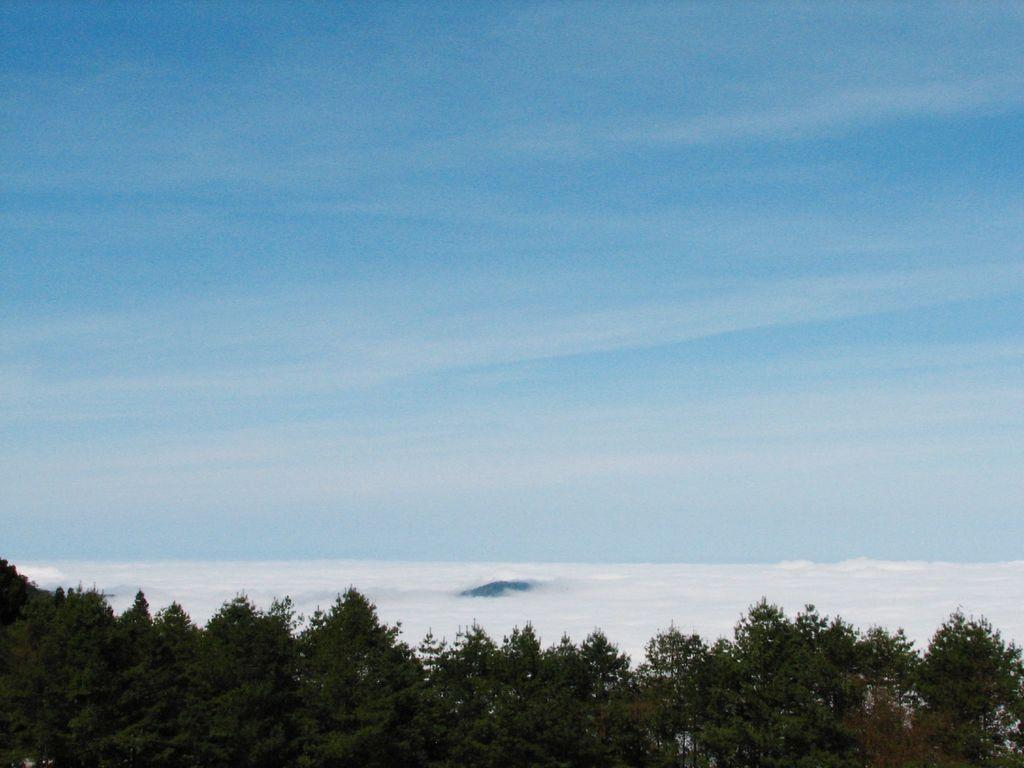What type of vegetation can be seen in the image? There are trees in the image. Where are the trees located in relation to the image? The trees are in the foreground of the image. What part of the natural environment is visible in the background of the image? The sky is visible in the background of the image. What type of drink is being served in the image? There is no drink present in the image; it only features trees in the foreground and the sky in the background. 